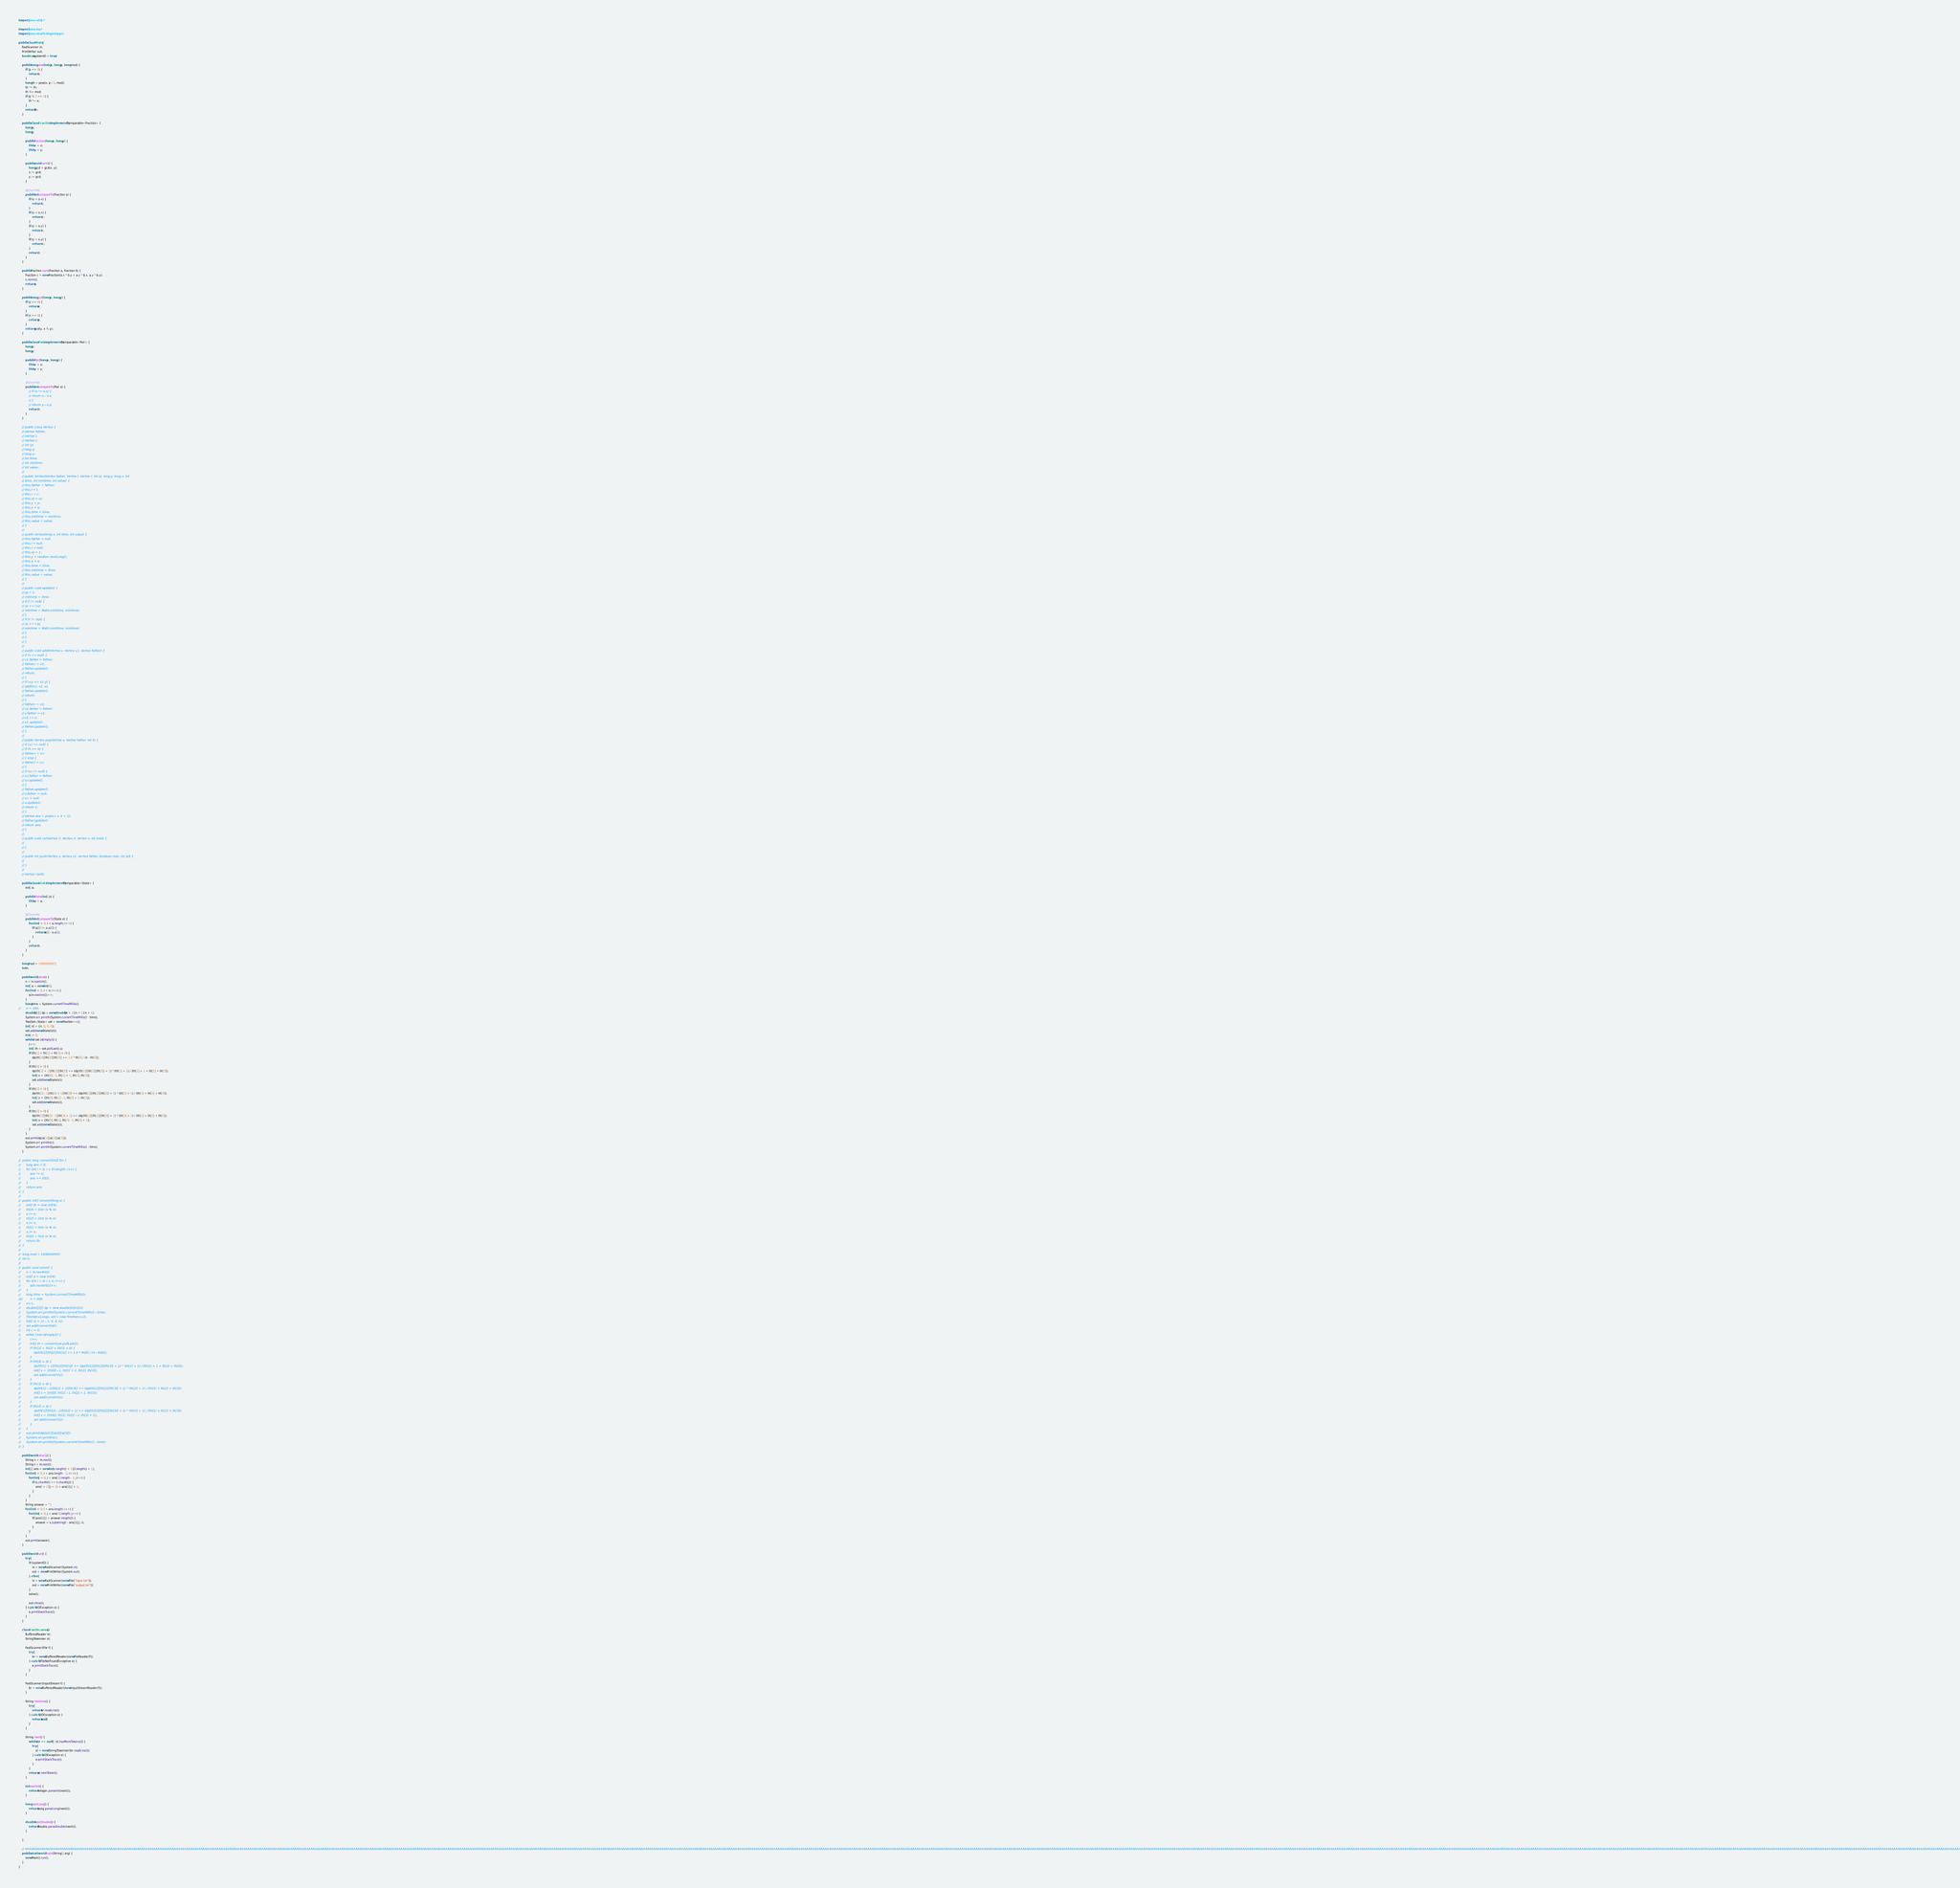<code> <loc_0><loc_0><loc_500><loc_500><_Java_>import java.util.*;

import java.io.*;
import java.math.BigInteger;

public class Main {
	FastScanner in;
	PrintWriter out;
	boolean systemIO = true;
	
	public long pow(long x, long p, long mod) {
		if (p <= 0) {
			return 1;
		}
		long th = pow(x, p / 2, mod);
		th *= th;
		th %= mod;
		if (p % 2 == 1) {
			th *= x;
		}
		return th;
	}

	public class Fraction implements Comparable<Fraction> {
		long x;
		long y;

		public Fraction(long x, long y) {
			this.x = x;
			this.y = y;
		}

		public void norm() {
			long gcd = gcd(x, y);
			x /= gcd;
			y /= gcd;
		}

		@Override
		public int compareTo(Fraction o) {
			if (x > o.x) {
				return 1;
			}
			if (x < o.x) {
				return -1;
			}
			if (y > o.y) {
				return 1;
			}
			if (y < o.y) {
				return -1;
			}
			return 0;
		}
	}

	public Fraction sum(Fraction a, Fraction b) {
		Fraction c = new Fraction(a.x * b.y + a.y * b.x, a.y * b.y);
		c.norm();
		return c;
	}

	public long gcd(long x, long y) {
		if (y == 0) {
			return x;
		}
		if (x == 0) {
			return y;
		}
		return gcd(y, x % y);
	}

	public class Pair implements Comparable<Pair> {
		long x;
		long y;

		public Pair(long x, long y) {
			this.x = x;
			this.y = y;
		}

		@Override
		public int compareTo(Pair o) {
			// if (x != o.x) {
			// return x - o.x;
			// }
			// return y - o.y;
			return 0;
		}
	}

	// public class Vertex {
	// Vertex father;
	// Vertex l;
	// Vertex r;
	// int sz;
	// long y;
	// long x;
	// int time;
	// int mintime;
	// int value;
	//
	// public Vertex(Vertex father, Vertex l, Vertex r, int sz, long y, long x, int
	// time, int mintime, int value) {
	// this.father = father;
	// this.l = l;
	// this.r = r;
	// this.sz = sz;
	// this.y = y;
	// this.x = x;
	// this.time = time;
	// this.mintime = mintime;
	// this.value = value;
	// }
	//
	// public Vertex(long x, int time, int value) {
	// this.father = null;
	// this.l = null;
	// this.r = null;
	// this.sz = 1;
	// this.y = random.nextLong();
	// this.x = x;
	// this.time = time;
	// this.mintime = time;
	// this.value = value;
	// }
	//
	// public void update() {
	// sz = 1;
	// mintime = time;
	// if (l != null) {
	// sz += l.sz;
	// mintime = Math.min(time, mintime);
	// }
	// if (r != null) {
	// sz += r.sz;
	// mintime = Math.min(time, mintime);
	// }
	// }
	// }
	//
	// public void add0(Vertex v, Vertex v1, Vertex father) {
	// if (v == null) {
	// v1.father = father;
	// father.r = v1;
	// father.update();
	// return;
	// }
	// if (v.y >= v1.y) {
	// add0(v.r, v1, v);
	// father.update();
	// return;
	// }
	// father.r = v1;
	// v1.father = father;
	// v.father = v1;
	// v1.l = v;
	// v1.update();
	// father.update();
	// }
	//
	// public Vertex pop(Vertex v, Vertex father, int h) {
	// if (v.l == null) {
	// if (h == 0) {
	// father.r = v.r;
	// } else {
	// father.l = v.r;
	// }
	// if (v.r != null) {
	// v.r.father = father;
	// v.r.update();
	// }
	// father.update();
	// v.father = null;
	// v.r = null;
	// v.update();
	// return v;
	// }
	// Vertex ans = pop(v.l, v, h + 1);
	// father.update();
	// return ans;
	// }
	//
	// public void cut(Vertex rl, Vertex rr, Vertex v, int mint) {
	//
	// }
	//
	// public int push(Vertex v, Vertex v1, Vertex father, boolean rson, int szl) {
	//
	// }
	//
	// Vertex root0;
	
	public class State implements Comparable<State> {
		int[] a;

		public State(int[] a) {
			this.a = a;
		}

		@Override
		public int compareTo(State o) {
			for (int i = 0; i < a.length; i++) {
				if (a[i] != o.a[i]) {
					return a[i] - o.a[i];
				}
			}
			return 0;
		}
	}
	
	long mod = 1000000007;
	int n;
	
	public void solve() {
		n = in.nextInt();
		int[] a = new int[4];
		for (int i = 0; i < n; i++) {
			a[in.nextInt()]++;
		}
		long time = System.currentTimeMillis();
//		n = 300;
		double[][][] dp = new double[n + 1][n + 1][n + 1];
		System.err.println(System.currentTimeMillis() - time);
		TreeSet<State> set = new TreeSet<>();
		int[] st = {n, 0, 0, 0};
		set.add(new State(st));
		int c = 0;
		while (!set.isEmpty()) {
			c++;
			int[] th = set.pollLast().a;
			if (th[1] + th[2] + th[3] > 0) {
				dp[th[1]][th[2]][th[3]] += 1.0 * th[0] / (n - th[0]);
			}
			if (th[0] > 0) {
				dp[th[1] + 1][th[2]][th[3]] += (dp[th[1]][th[2]][th[3]] + 1) * (th[1] + 1) / (th[1] + 1 + th[2] + th[3]);
				int[] s = {th[0] - 1, th[1] + 1, th[2], th[3]};
				set.add(new State(s));
			}
			if (th[1] > 0) {
				dp[th[1] - 1][th[2] + 1][th[3]] += (dp[th[1]][th[2]][th[3]] + 1) * (th[2] + 1) / (th[1] + th[2] + th[3]);
				int[] s = {th[0], th[1] - 1, th[2] + 1, th[3]};
				set.add(new State(s));
			}
			if (th[2] > 0) {
				dp[th[1]][th[2] - 1][th[3] + 1] += (dp[th[1]][th[2]][th[3]] + 1) * (th[3] + 1) / (th[1] + th[2] + th[3]);
				int[] s = {th[0], th[1], th[2] - 1, th[3] + 1};
				set.add(new State(s));
			}
		}
		out.print(dp[a[1]][a[2]][a[3]]);
		System.err.println(c);
		System.err.println(System.currentTimeMillis() - time);
	}
	
//	public long convert(int[] th) {
//		long ans = 0;
//		for (int i = 0; i < th.length; i++) {
//			ans *= n;
//			ans += th[i];
//		}
//		return ans;
//	}
//	
//	public int[] convert(long x) {
//		int[] th = new int[4];
//		th[3] = (int) (x % n);
//		x /= n;
//		th[2] = (int) (x % n);
//		x /= n;
//		th[1] = (int) (x % n);
//		x /= n;
//		th[0] = (int) (x % n);
//		return th;
//	}
//	
//	long mod = 1000000007;
//	int n;
//	
//	public void solve() {
//		n = in.nextInt();
//		int[] a = new int[4];
//		for (int i = 0; i < n; i++) {
//			a[in.nextInt()]++;
//		}
//		long time = System.currentTimeMillis();
////		n = 300;
//		n++;
//		double[][][] dp = new double[n][n][n];
//		System.err.println(System.currentTimeMillis() - time);
//		TreeSet<Long> set = new TreeSet<>();
//		int[] st = {n - 1, 0, 0, 0};
//		set.add(convert(st));
//		int c = 0;
//		while (!set.isEmpty()) {
//			c++;
//			int[] th = convert(set.pollLast());
//			if (th[1] + th[2] + th[3] > 0) {
//				dp[th[1]][th[2]][th[3]] += 1.0 * th[0] / (n - th[0]);
//			}
//			if (th[0] > 0) {
//				dp[th[1] + 1][th[2]][th[3]] += (dp[th[1]][th[2]][th[3]] + 1) * (th[1] + 1) / (th[1] + 1 + th[2] + th[3]);
//				int[] s = {th[0] - 1, th[1] + 1, th[2], th[3]};
//				set.add(convert(s));
//			}
//			if (th[1] > 0) {
//				dp[th[1] - 1][th[2] + 1][th[3]] += (dp[th[1]][th[2]][th[3]] + 1) * (th[2] + 1) / (th[1] + th[2] + th[3]);
//				int[] s = {th[0], th[1] - 1, th[2] + 1, th[3]};
//				set.add(convert(s));
//			}
//			if (th[2] > 0) {
//				dp[th[1]][th[2] - 1][th[3] + 1] += (dp[th[1]][th[2]][th[3]] + 1) * (th[3] + 1) / (th[1] + th[2] + th[3]);
//				int[] s = {th[0], th[1], th[2] - 1, th[3] + 1};
//				set.add(convert(s));
//			}
//		}
//		out.print(dp[a[1]][a[2]][a[3]]);
//		System.err.println(c);
//		System.err.println(System.currentTimeMillis() - time);
//	}
	
	public void solve1() {
		String s = in.next();
		String t = in.next();
		int[][] ans = new int[s.length() + 1][t.length() + 1];
		for (int i = 0; i < ans.length - 1; i++) {
			for (int j = 0; j < ans[0].length - 1; j++) {
				if (s.charAt(i) == t.charAt(j)) {
					ans[i + 1][j + 1] = ans[i][j] + 1;
				}
			}
		}
		String answer = "";
		for (int i = 0; i < ans.length; i++) {
			for (int j = 0; j < ans[0].length; j++) {
				if (ans[i][j] > answer.length()) {
					answer = s.substring(i - ans[i][j], i);
				}
			}
		}
		out.print(answer);
	}

	public void run() {
		try {
			if (systemIO) {
				in = new FastScanner(System.in);
				out = new PrintWriter(System.out);
			} else {
				in = new FastScanner(new File("input.txt"));
				out = new PrintWriter(new File("output.txt"));
			}
			solve();

			out.close();
		} catch (IOException e) {
			e.printStackTrace();
		}
	}

	class FastScanner {
		BufferedReader br;
		StringTokenizer st;

		FastScanner(File f) {
			try {
				br = new BufferedReader(new FileReader(f));
			} catch (FileNotFoundException e) {
				e.printStackTrace();
			}
		}

		FastScanner(InputStream f) {
			br = new BufferedReader(new InputStreamReader(f));
		}

		String nextLine() {
			try {
				return br.readLine();
			} catch (IOException e) {
				return null;
			}
		}

		String next() {
			while (st == null || !st.hasMoreTokens()) {
				try {
					st = new StringTokenizer(br.readLine());
				} catch (IOException e) {
					e.printStackTrace();
				}
			}
			return st.nextToken();
		}

		int nextInt() {
			return Integer.parseInt(next());
		}

		long nextLong() {
			return Long.parseLong(next());
		}

		double nextDouble() {
			return Double.parseDouble(next());
		}

	}

	// AAAAAAAAAAAAAAAAAAAAAAAAAAAAAAAAAAAAAAAAAAAAAAAAAAAAAAAAAAAAAAAAAAAAAAAAAAAAAAAAAAAAAAAAAAAAAAAAAAAAAAAAAAAAAAAAAAAAAAAAAAAAAAAAAAAAAAAAAAAAAAAAAAAAAAAAAAAAAAAAAAAAAAAAAAAAAAAAAAAAAAAAAAAAAAAAAAAAAAAAAAAAAAAAAAAAAAAAAAAAAAAAAAAAAAAAAAAAAAAAAAAAAAAAAAAAAAAAAAAAAAAAAAAAAAAAAAAAAAAAAAAAAAAAAAAAAAAAAAAAAAAAAAAAAAAAAAAAAAAAAAAAAAAAAAAAAAAAAAAAAAAAAAAAAAAAAAAAAAAAAAAAAAAAAAAAAAAAAAAAAAAAAAAAAAAAAAAAAAAAAAAAAAAAAAAAAAAAAAAAAAAAAAAAAAAAAAAAAAAAAAAAAAAAAAAAAAAAAAAAAAAAAAAAAAAAAAAAAAAAAAAAAAAAAAAAAAAAAAAAAAAAAAAAAAAAAAAAAAAAAAAAAAAAAAAAAAAAAAAAAAAAAAAAAAAAAAAAAAAAAAAAAAAAAAAAAAAAAAAAAAAAAAAAAAAAAAAAAAAAAAAAAAAAAAAAAAAAAAAAAAAAAAAAAAAAAAAAAAAAAAAAAAAAAAAAAAAAAAAAAAAAAAAAAAAAAAAAAAAAAAAAAAAAAAAAAAAAAAAAAAAAAAAAAAAAAAAAAAAAAAAAAAAAAAAAAAAAAAAAAAAAAAAAAAAAAAAAAAAAAAAAAAAAAAAAAAAAAAAAAAAAAAAAAAAAAAAAAAAAAAAAAAAAAAAAAAAAAAAAAAAAAAAAAAAAAAAAAAAAAAAAAAAAAAAAAAAAAAAAAAAAAAAAAAAAAAAAAAAAAAAAAAAAAAAAAAAAAAAAAAAAAAAAAAAAAAAAAAAAAAAAAAAAAAAAAAAAAAAAAAAAAAAAAAAAAAAAAAAAAAAAAAAAAAAAAAAAAAAAAAAAAAAAAAAAAAAAAAAA
	public static void main(String[] arg) {
		new Main().run();
	}
}</code> 